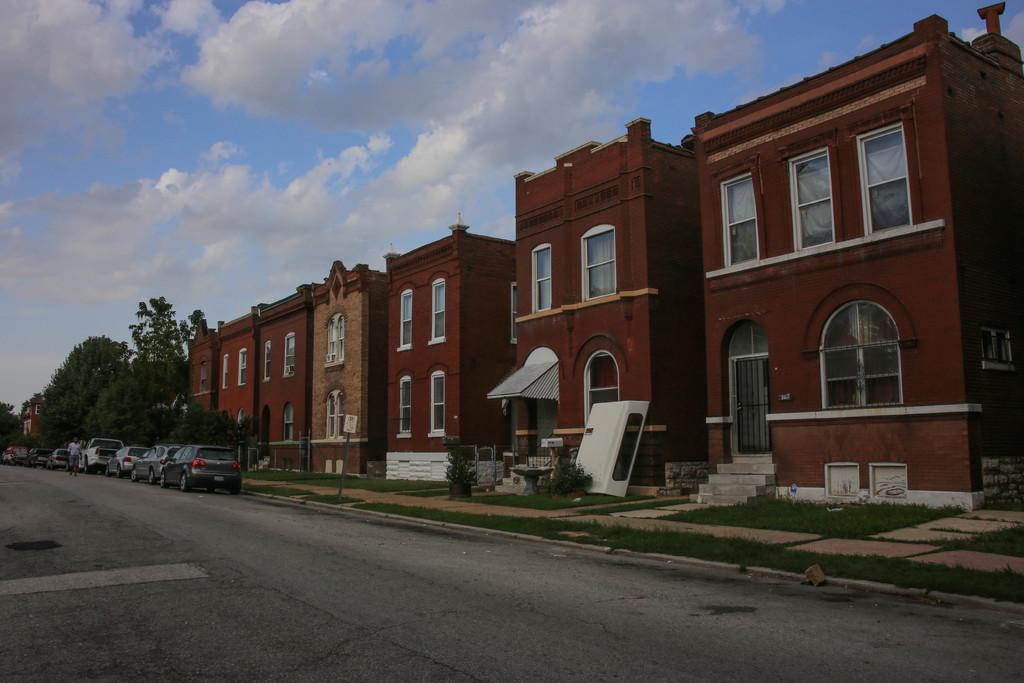Describe this image in one or two sentences. In this image I can see at the bottom it is the road, few cars are parked on it. On the right side there are buildings, at the back side there are trees, at the top there is the cloudy sky. 